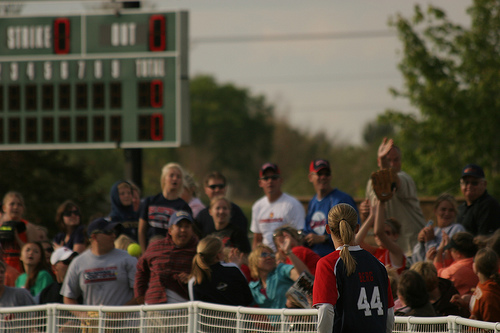<image>
Is the hat on the woman? No. The hat is not positioned on the woman. They may be near each other, but the hat is not supported by or resting on top of the woman. 